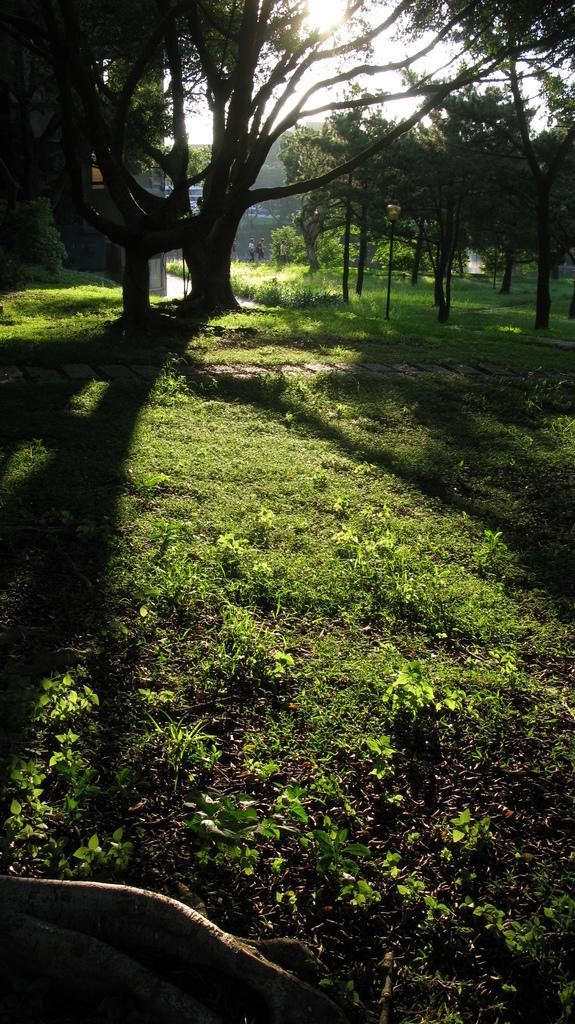What type of vegetation is present on the ground in the image? There is grass on the ground in the image. What other natural elements can be seen in the image? There are trees in the image. What can be seen in the background of the image? The sky and a building are visible in the background of the image. How many people are in the image? There are two persons in the image. Can you see any birds in the image? There are no birds present in the image. Is there a stream visible in the image? There is no stream present in the image. 